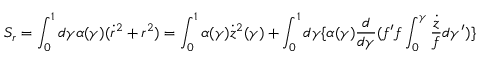<formula> <loc_0><loc_0><loc_500><loc_500>S _ { r } = \int _ { 0 } ^ { 1 } d \gamma \alpha ( \gamma ) ( \dot { r } ^ { 2 } + r ^ { 2 } ) = \int _ { 0 } ^ { 1 } \alpha ( \gamma ) \dot { z } ^ { 2 } ( \gamma ) + \int _ { 0 } ^ { 1 } d \gamma \{ \alpha ( \gamma ) \frac { d } { d \gamma } ( f ^ { \prime } f \int _ { 0 } ^ { \gamma } \frac { \dot { z } } { f } d \gamma ^ { \prime } ) \}</formula> 